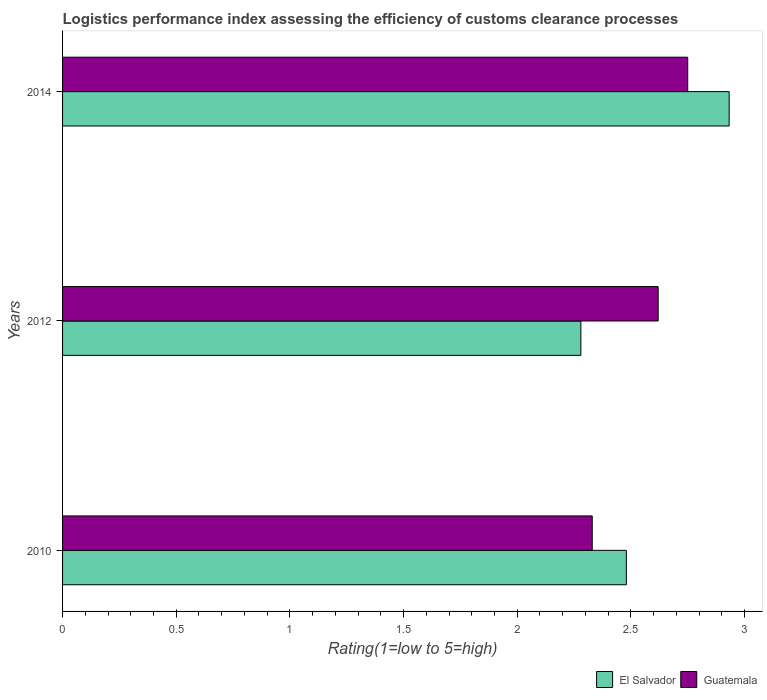How many different coloured bars are there?
Make the answer very short. 2. How many groups of bars are there?
Provide a short and direct response. 3. Are the number of bars on each tick of the Y-axis equal?
Ensure brevity in your answer.  Yes. How many bars are there on the 1st tick from the bottom?
Your response must be concise. 2. What is the label of the 2nd group of bars from the top?
Provide a short and direct response. 2012. In how many cases, is the number of bars for a given year not equal to the number of legend labels?
Keep it short and to the point. 0. What is the Logistic performance index in Guatemala in 2012?
Offer a very short reply. 2.62. Across all years, what is the maximum Logistic performance index in El Salvador?
Keep it short and to the point. 2.93. Across all years, what is the minimum Logistic performance index in Guatemala?
Your response must be concise. 2.33. In which year was the Logistic performance index in Guatemala maximum?
Your response must be concise. 2014. In which year was the Logistic performance index in El Salvador minimum?
Your response must be concise. 2012. What is the difference between the Logistic performance index in El Salvador in 2012 and that in 2014?
Your response must be concise. -0.65. What is the difference between the Logistic performance index in El Salvador in 2010 and the Logistic performance index in Guatemala in 2014?
Give a very brief answer. -0.27. What is the average Logistic performance index in Guatemala per year?
Provide a short and direct response. 2.57. In the year 2012, what is the difference between the Logistic performance index in El Salvador and Logistic performance index in Guatemala?
Provide a short and direct response. -0.34. What is the ratio of the Logistic performance index in Guatemala in 2010 to that in 2014?
Ensure brevity in your answer.  0.85. Is the Logistic performance index in El Salvador in 2010 less than that in 2012?
Ensure brevity in your answer.  No. Is the difference between the Logistic performance index in El Salvador in 2010 and 2014 greater than the difference between the Logistic performance index in Guatemala in 2010 and 2014?
Make the answer very short. No. What is the difference between the highest and the second highest Logistic performance index in Guatemala?
Provide a short and direct response. 0.13. What is the difference between the highest and the lowest Logistic performance index in Guatemala?
Offer a very short reply. 0.42. What does the 1st bar from the top in 2014 represents?
Your answer should be compact. Guatemala. What does the 1st bar from the bottom in 2010 represents?
Give a very brief answer. El Salvador. How many bars are there?
Offer a very short reply. 6. How many years are there in the graph?
Your answer should be very brief. 3. What is the difference between two consecutive major ticks on the X-axis?
Provide a succinct answer. 0.5. Are the values on the major ticks of X-axis written in scientific E-notation?
Your response must be concise. No. Does the graph contain any zero values?
Offer a terse response. No. Does the graph contain grids?
Your answer should be compact. No. Where does the legend appear in the graph?
Offer a very short reply. Bottom right. How are the legend labels stacked?
Your answer should be very brief. Horizontal. What is the title of the graph?
Keep it short and to the point. Logistics performance index assessing the efficiency of customs clearance processes. What is the label or title of the X-axis?
Offer a terse response. Rating(1=low to 5=high). What is the Rating(1=low to 5=high) of El Salvador in 2010?
Your answer should be very brief. 2.48. What is the Rating(1=low to 5=high) of Guatemala in 2010?
Your answer should be very brief. 2.33. What is the Rating(1=low to 5=high) of El Salvador in 2012?
Offer a terse response. 2.28. What is the Rating(1=low to 5=high) of Guatemala in 2012?
Your answer should be very brief. 2.62. What is the Rating(1=low to 5=high) of El Salvador in 2014?
Your answer should be very brief. 2.93. What is the Rating(1=low to 5=high) in Guatemala in 2014?
Keep it short and to the point. 2.75. Across all years, what is the maximum Rating(1=low to 5=high) of El Salvador?
Offer a terse response. 2.93. Across all years, what is the maximum Rating(1=low to 5=high) in Guatemala?
Give a very brief answer. 2.75. Across all years, what is the minimum Rating(1=low to 5=high) in El Salvador?
Give a very brief answer. 2.28. Across all years, what is the minimum Rating(1=low to 5=high) of Guatemala?
Keep it short and to the point. 2.33. What is the total Rating(1=low to 5=high) in El Salvador in the graph?
Provide a short and direct response. 7.69. What is the total Rating(1=low to 5=high) in Guatemala in the graph?
Offer a terse response. 7.7. What is the difference between the Rating(1=low to 5=high) of El Salvador in 2010 and that in 2012?
Your response must be concise. 0.2. What is the difference between the Rating(1=low to 5=high) in Guatemala in 2010 and that in 2012?
Provide a short and direct response. -0.29. What is the difference between the Rating(1=low to 5=high) in El Salvador in 2010 and that in 2014?
Provide a succinct answer. -0.45. What is the difference between the Rating(1=low to 5=high) of Guatemala in 2010 and that in 2014?
Offer a very short reply. -0.42. What is the difference between the Rating(1=low to 5=high) in El Salvador in 2012 and that in 2014?
Ensure brevity in your answer.  -0.65. What is the difference between the Rating(1=low to 5=high) in Guatemala in 2012 and that in 2014?
Make the answer very short. -0.13. What is the difference between the Rating(1=low to 5=high) of El Salvador in 2010 and the Rating(1=low to 5=high) of Guatemala in 2012?
Ensure brevity in your answer.  -0.14. What is the difference between the Rating(1=low to 5=high) of El Salvador in 2010 and the Rating(1=low to 5=high) of Guatemala in 2014?
Offer a terse response. -0.27. What is the difference between the Rating(1=low to 5=high) in El Salvador in 2012 and the Rating(1=low to 5=high) in Guatemala in 2014?
Give a very brief answer. -0.47. What is the average Rating(1=low to 5=high) in El Salvador per year?
Offer a very short reply. 2.56. What is the average Rating(1=low to 5=high) of Guatemala per year?
Provide a short and direct response. 2.57. In the year 2010, what is the difference between the Rating(1=low to 5=high) of El Salvador and Rating(1=low to 5=high) of Guatemala?
Offer a terse response. 0.15. In the year 2012, what is the difference between the Rating(1=low to 5=high) in El Salvador and Rating(1=low to 5=high) in Guatemala?
Offer a terse response. -0.34. In the year 2014, what is the difference between the Rating(1=low to 5=high) of El Salvador and Rating(1=low to 5=high) of Guatemala?
Keep it short and to the point. 0.18. What is the ratio of the Rating(1=low to 5=high) in El Salvador in 2010 to that in 2012?
Keep it short and to the point. 1.09. What is the ratio of the Rating(1=low to 5=high) of Guatemala in 2010 to that in 2012?
Give a very brief answer. 0.89. What is the ratio of the Rating(1=low to 5=high) in El Salvador in 2010 to that in 2014?
Provide a succinct answer. 0.85. What is the ratio of the Rating(1=low to 5=high) of Guatemala in 2010 to that in 2014?
Ensure brevity in your answer.  0.85. What is the ratio of the Rating(1=low to 5=high) of El Salvador in 2012 to that in 2014?
Offer a terse response. 0.78. What is the ratio of the Rating(1=low to 5=high) of Guatemala in 2012 to that in 2014?
Your answer should be compact. 0.95. What is the difference between the highest and the second highest Rating(1=low to 5=high) in El Salvador?
Give a very brief answer. 0.45. What is the difference between the highest and the second highest Rating(1=low to 5=high) in Guatemala?
Ensure brevity in your answer.  0.13. What is the difference between the highest and the lowest Rating(1=low to 5=high) in El Salvador?
Provide a short and direct response. 0.65. What is the difference between the highest and the lowest Rating(1=low to 5=high) in Guatemala?
Offer a very short reply. 0.42. 